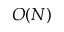Convert formula to latex. <formula><loc_0><loc_0><loc_500><loc_500>O ( N )</formula> 